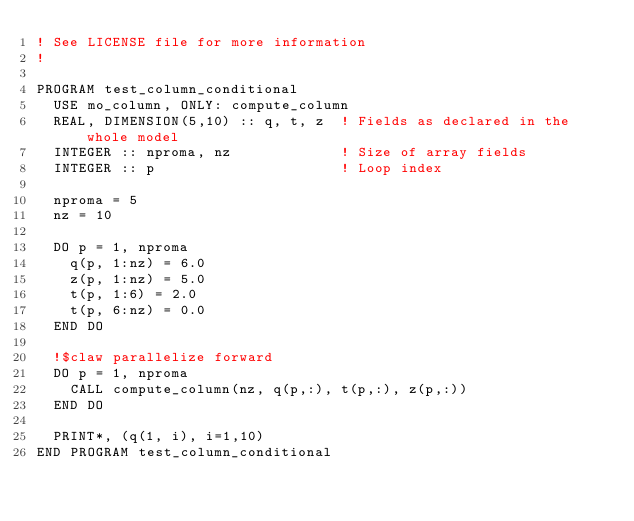Convert code to text. <code><loc_0><loc_0><loc_500><loc_500><_FORTRAN_>! See LICENSE file for more information
!

PROGRAM test_column_conditional
  USE mo_column, ONLY: compute_column
  REAL, DIMENSION(5,10) :: q, t, z  ! Fields as declared in the whole model
  INTEGER :: nproma, nz             ! Size of array fields
  INTEGER :: p                      ! Loop index

  nproma = 5
  nz = 10

  DO p = 1, nproma
    q(p, 1:nz) = 6.0
    z(p, 1:nz) = 5.0
    t(p, 1:6) = 2.0
    t(p, 6:nz) = 0.0
  END DO

  !$claw parallelize forward
  DO p = 1, nproma
    CALL compute_column(nz, q(p,:), t(p,:), z(p,:))
  END DO

  PRINT*, (q(1, i), i=1,10)
END PROGRAM test_column_conditional
</code> 